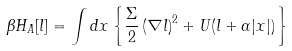Convert formula to latex. <formula><loc_0><loc_0><loc_500><loc_500>\beta H _ { A } [ l ] = \int d { x } \left \{ \frac { \Sigma } { 2 } \left ( \nabla l \right ) ^ { 2 } + U ( l + \alpha | x | ) \right \}</formula> 